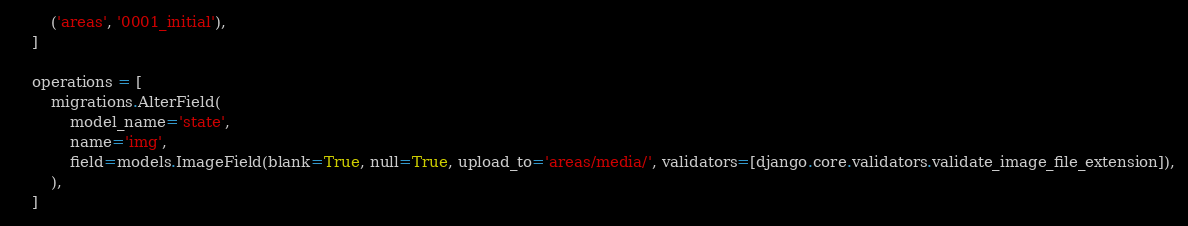<code> <loc_0><loc_0><loc_500><loc_500><_Python_>        ('areas', '0001_initial'),
    ]

    operations = [
        migrations.AlterField(
            model_name='state',
            name='img',
            field=models.ImageField(blank=True, null=True, upload_to='areas/media/', validators=[django.core.validators.validate_image_file_extension]),
        ),
    ]
</code> 